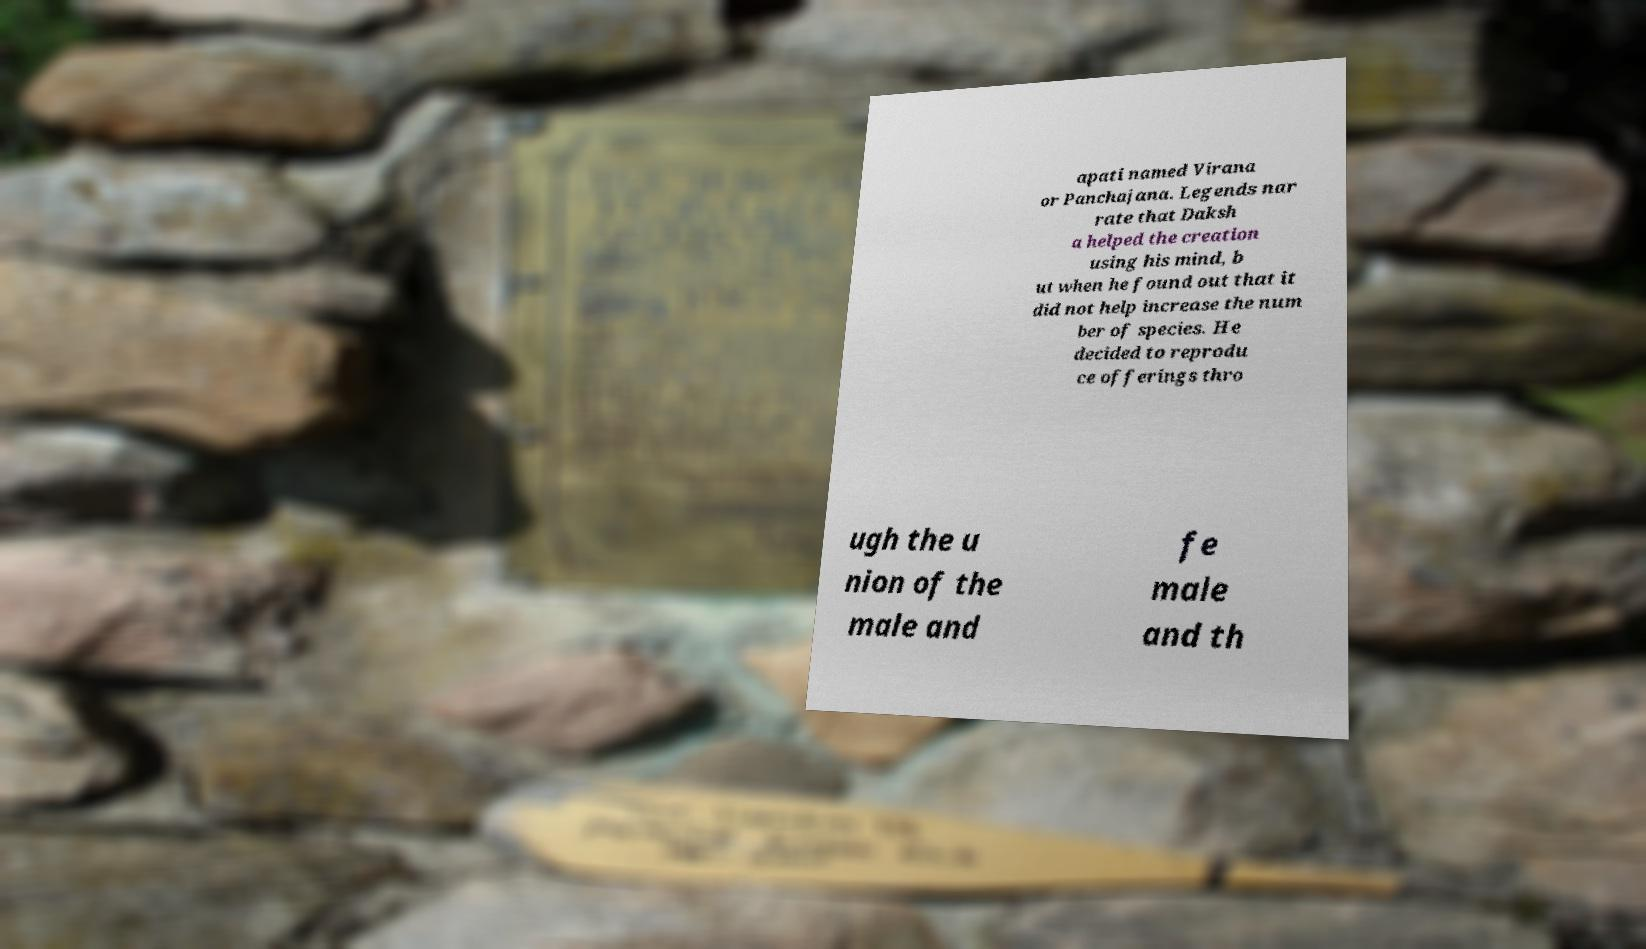For documentation purposes, I need the text within this image transcribed. Could you provide that? apati named Virana or Panchajana. Legends nar rate that Daksh a helped the creation using his mind, b ut when he found out that it did not help increase the num ber of species. He decided to reprodu ce offerings thro ugh the u nion of the male and fe male and th 